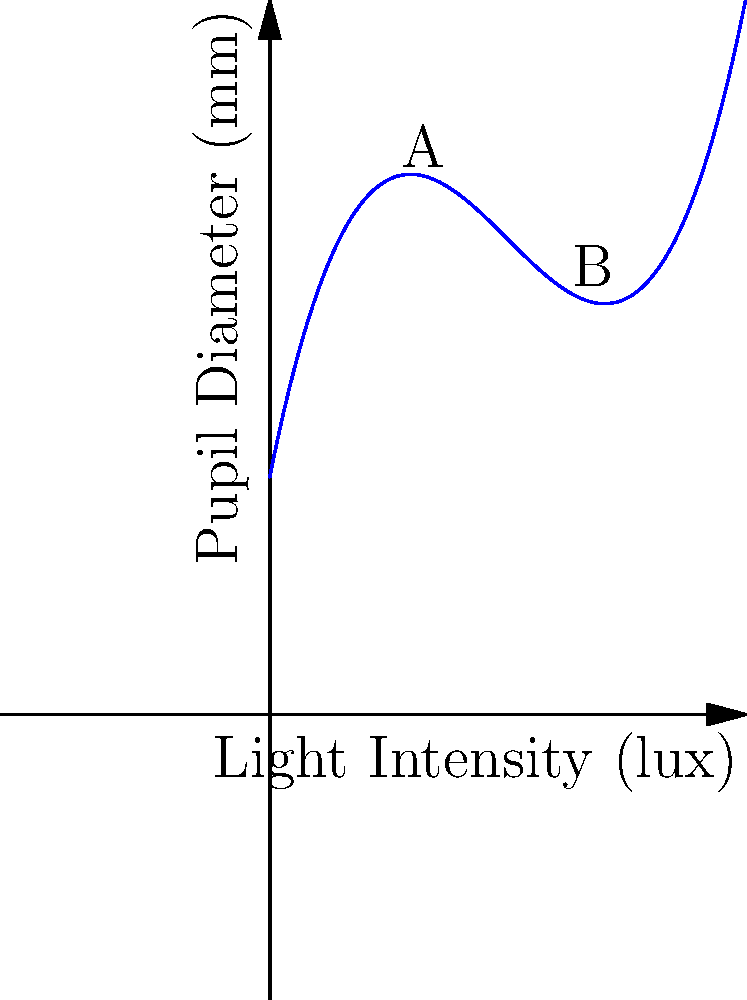The graph shows the relationship between light intensity and pupil diameter using a polynomial curve. At which point does the pupil diameter start to increase again as light intensity increases? What could be a possible explanation for this phenomenon in the context of ophthalmology? To answer this question, we need to analyze the graph and understand the relationship between light intensity and pupil diameter:

1. The x-axis represents light intensity (in lux), while the y-axis represents pupil diameter (in mm).

2. The curve is a polynomial function, specifically a cubic function of the form $f(x) = ax^3 + bx^2 + cx + d$.

3. As we move along the x-axis from left to right (increasing light intensity), we observe that:
   a) Initially, the pupil diameter decreases rapidly (constriction).
   b) The rate of decrease slows down as we approach the minimum point.
   c) After the minimum point (around x = 3), the pupil diameter starts to increase again.

4. The point where the pupil diameter starts to increase again is the local minimum of the function, which occurs at point B on the graph (around x = 3).

5. In the context of ophthalmology, this phenomenon could be explained by:
   a) Initial pupil constriction in response to increasing light intensity is a normal physiological response (miosis).
   b) The unexpected dilation after a certain point (paradoxical dilation) could be due to:
      - Activation of the sympathetic nervous system in response to very bright light, overriding the parasympathetic response.
      - Potential damage to the iris muscles or neural pathways in extremely bright conditions.
      - A protective mechanism to prevent retinal damage by allowing less focused light to enter the eye, effectively reducing the intensity of light on any single point of the retina.

This type of response curve is important for ophthalmologists to understand, as it may indicate normal or abnormal pupillary responses in different lighting conditions.
Answer: Point B (x ≈ 3); Paradoxical dilation due to protective mechanisms or neural responses in extreme brightness. 